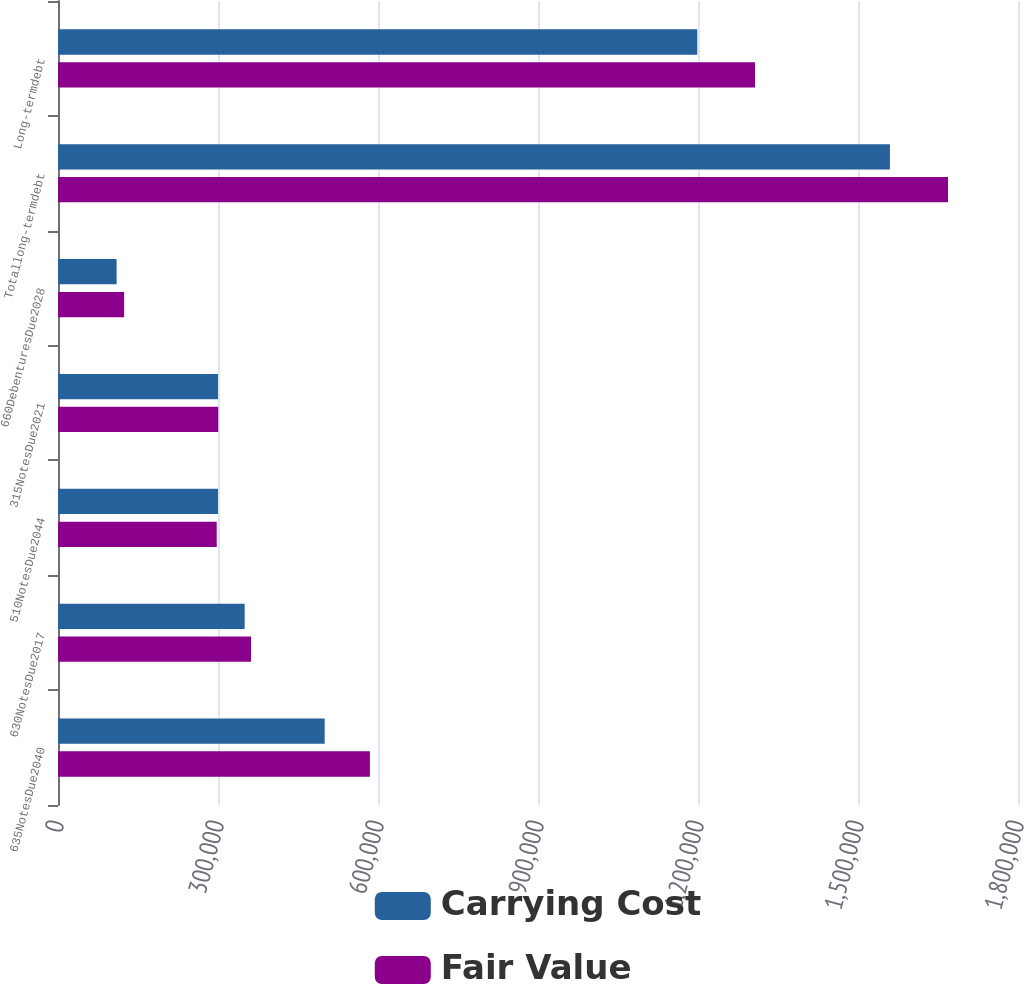<chart> <loc_0><loc_0><loc_500><loc_500><stacked_bar_chart><ecel><fcel>635NotesDue2040<fcel>630NotesDue2017<fcel>510NotesDue2044<fcel>315NotesDue2021<fcel>660DebenturesDue2028<fcel>Totallong-termdebt<fcel>Long-termdebt<nl><fcel>Carrying Cost<fcel>500000<fcel>350000<fcel>300000<fcel>300000<fcel>109895<fcel>1.5599e+06<fcel>1.19868e+06<nl><fcel>Fair Value<fcel>584850<fcel>361900<fcel>297600<fcel>300450<fcel>123984<fcel>1.66878e+06<fcel>1.30688e+06<nl></chart> 